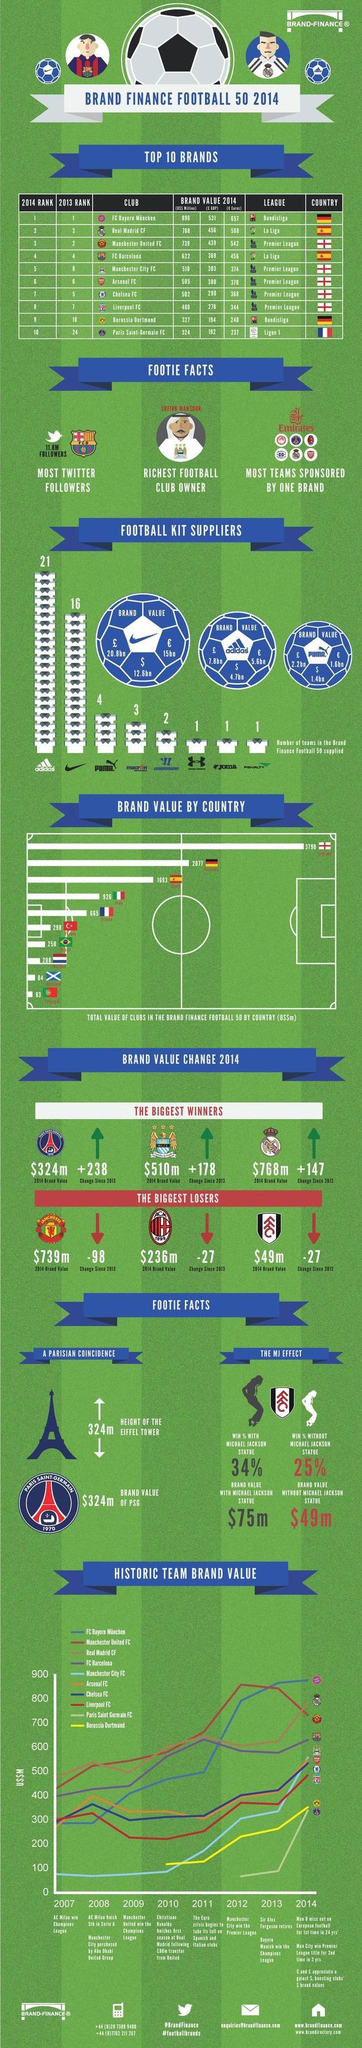List a handful of essential elements in this visual. The La Liga league includes top clubs such as Real Madrid CF and FC Barcelona. La Liga includes 2 clubs that participate in the league. Italy's football club has the fourth-highest brand value among all countries. There are currently three teams that have achieved a brand value of over 700 US million. The color code assigned to the team Borussia Dortmund is red, violet, yellow, and black. 